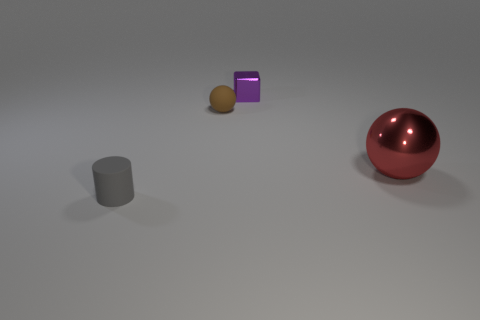What is the shape of the big red metallic thing? sphere 